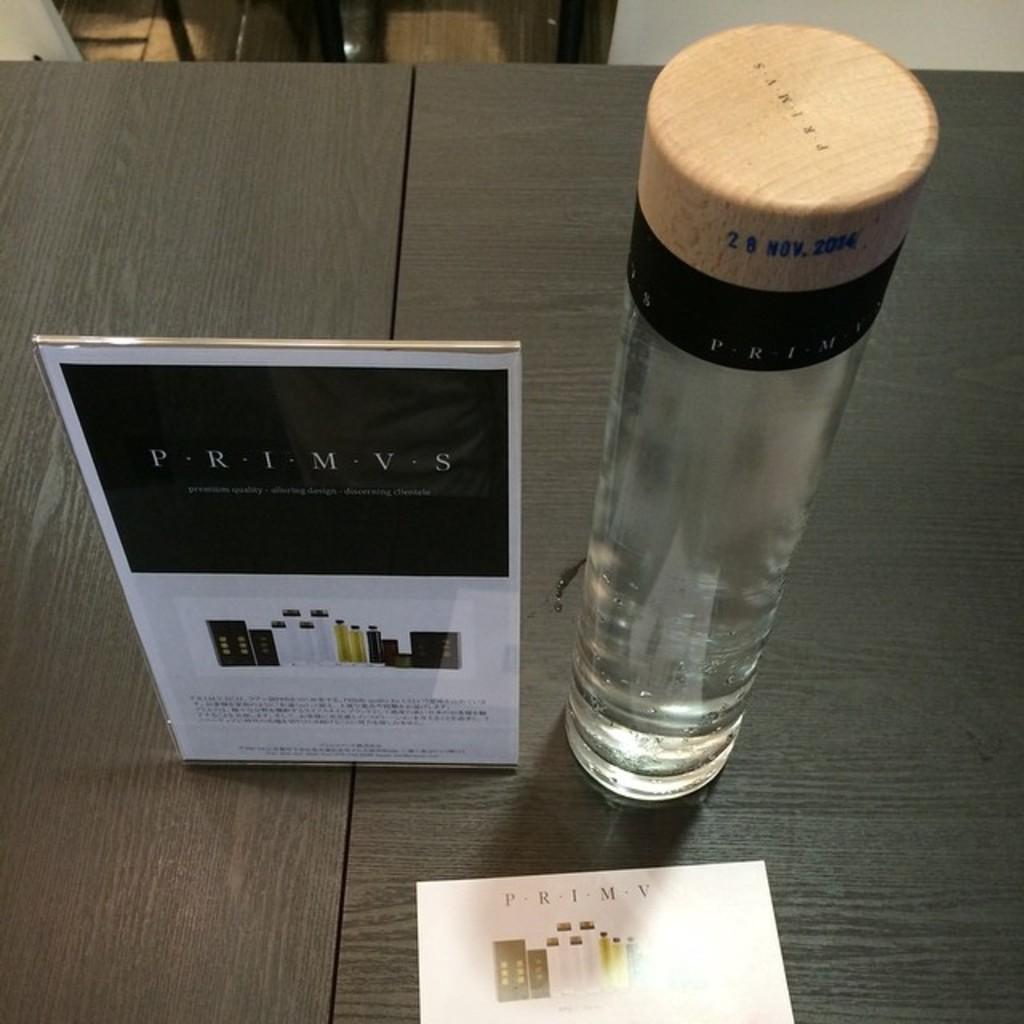What is the number on the wooden top?
Make the answer very short. 28. What is the date on the water bottle?
Your answer should be very brief. 28 nov 2014. 